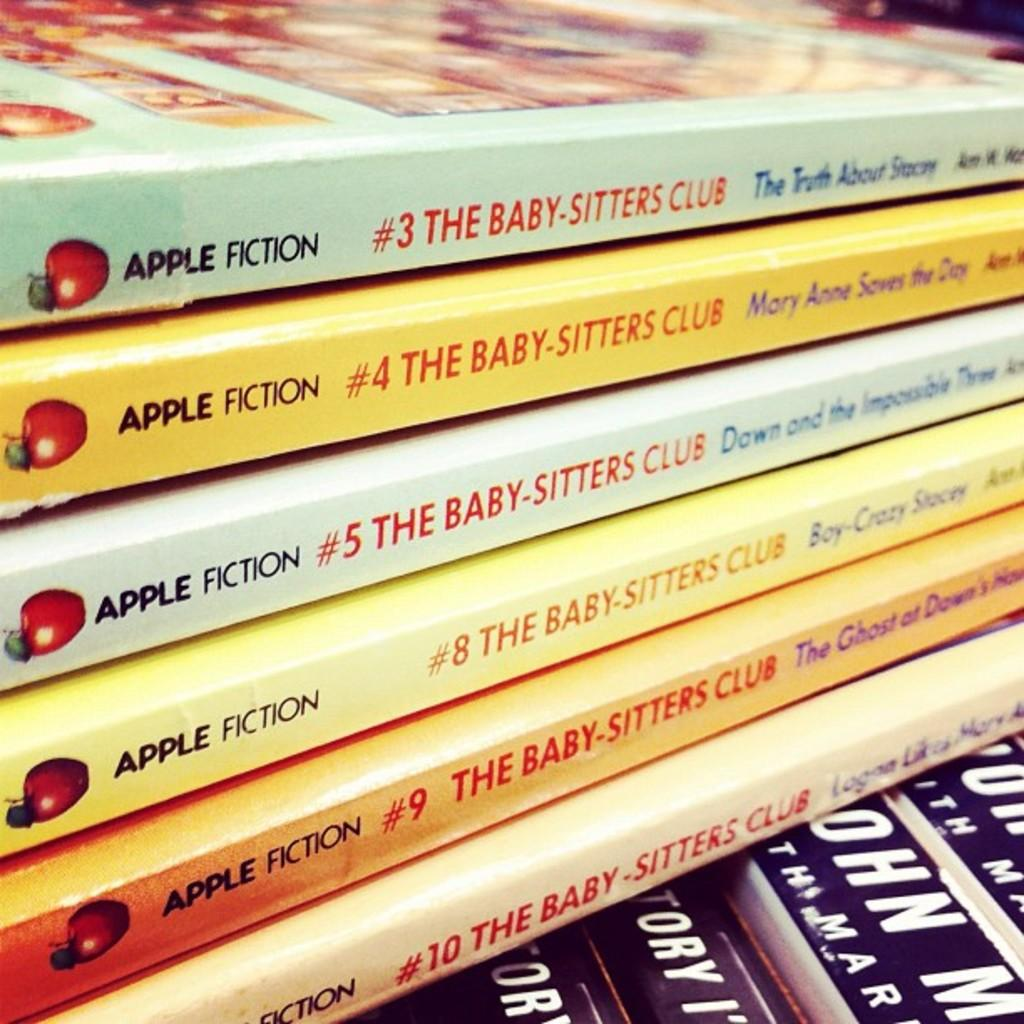<image>
Summarize the visual content of the image. A stack of six books in The Baby-Sitters Club series. 